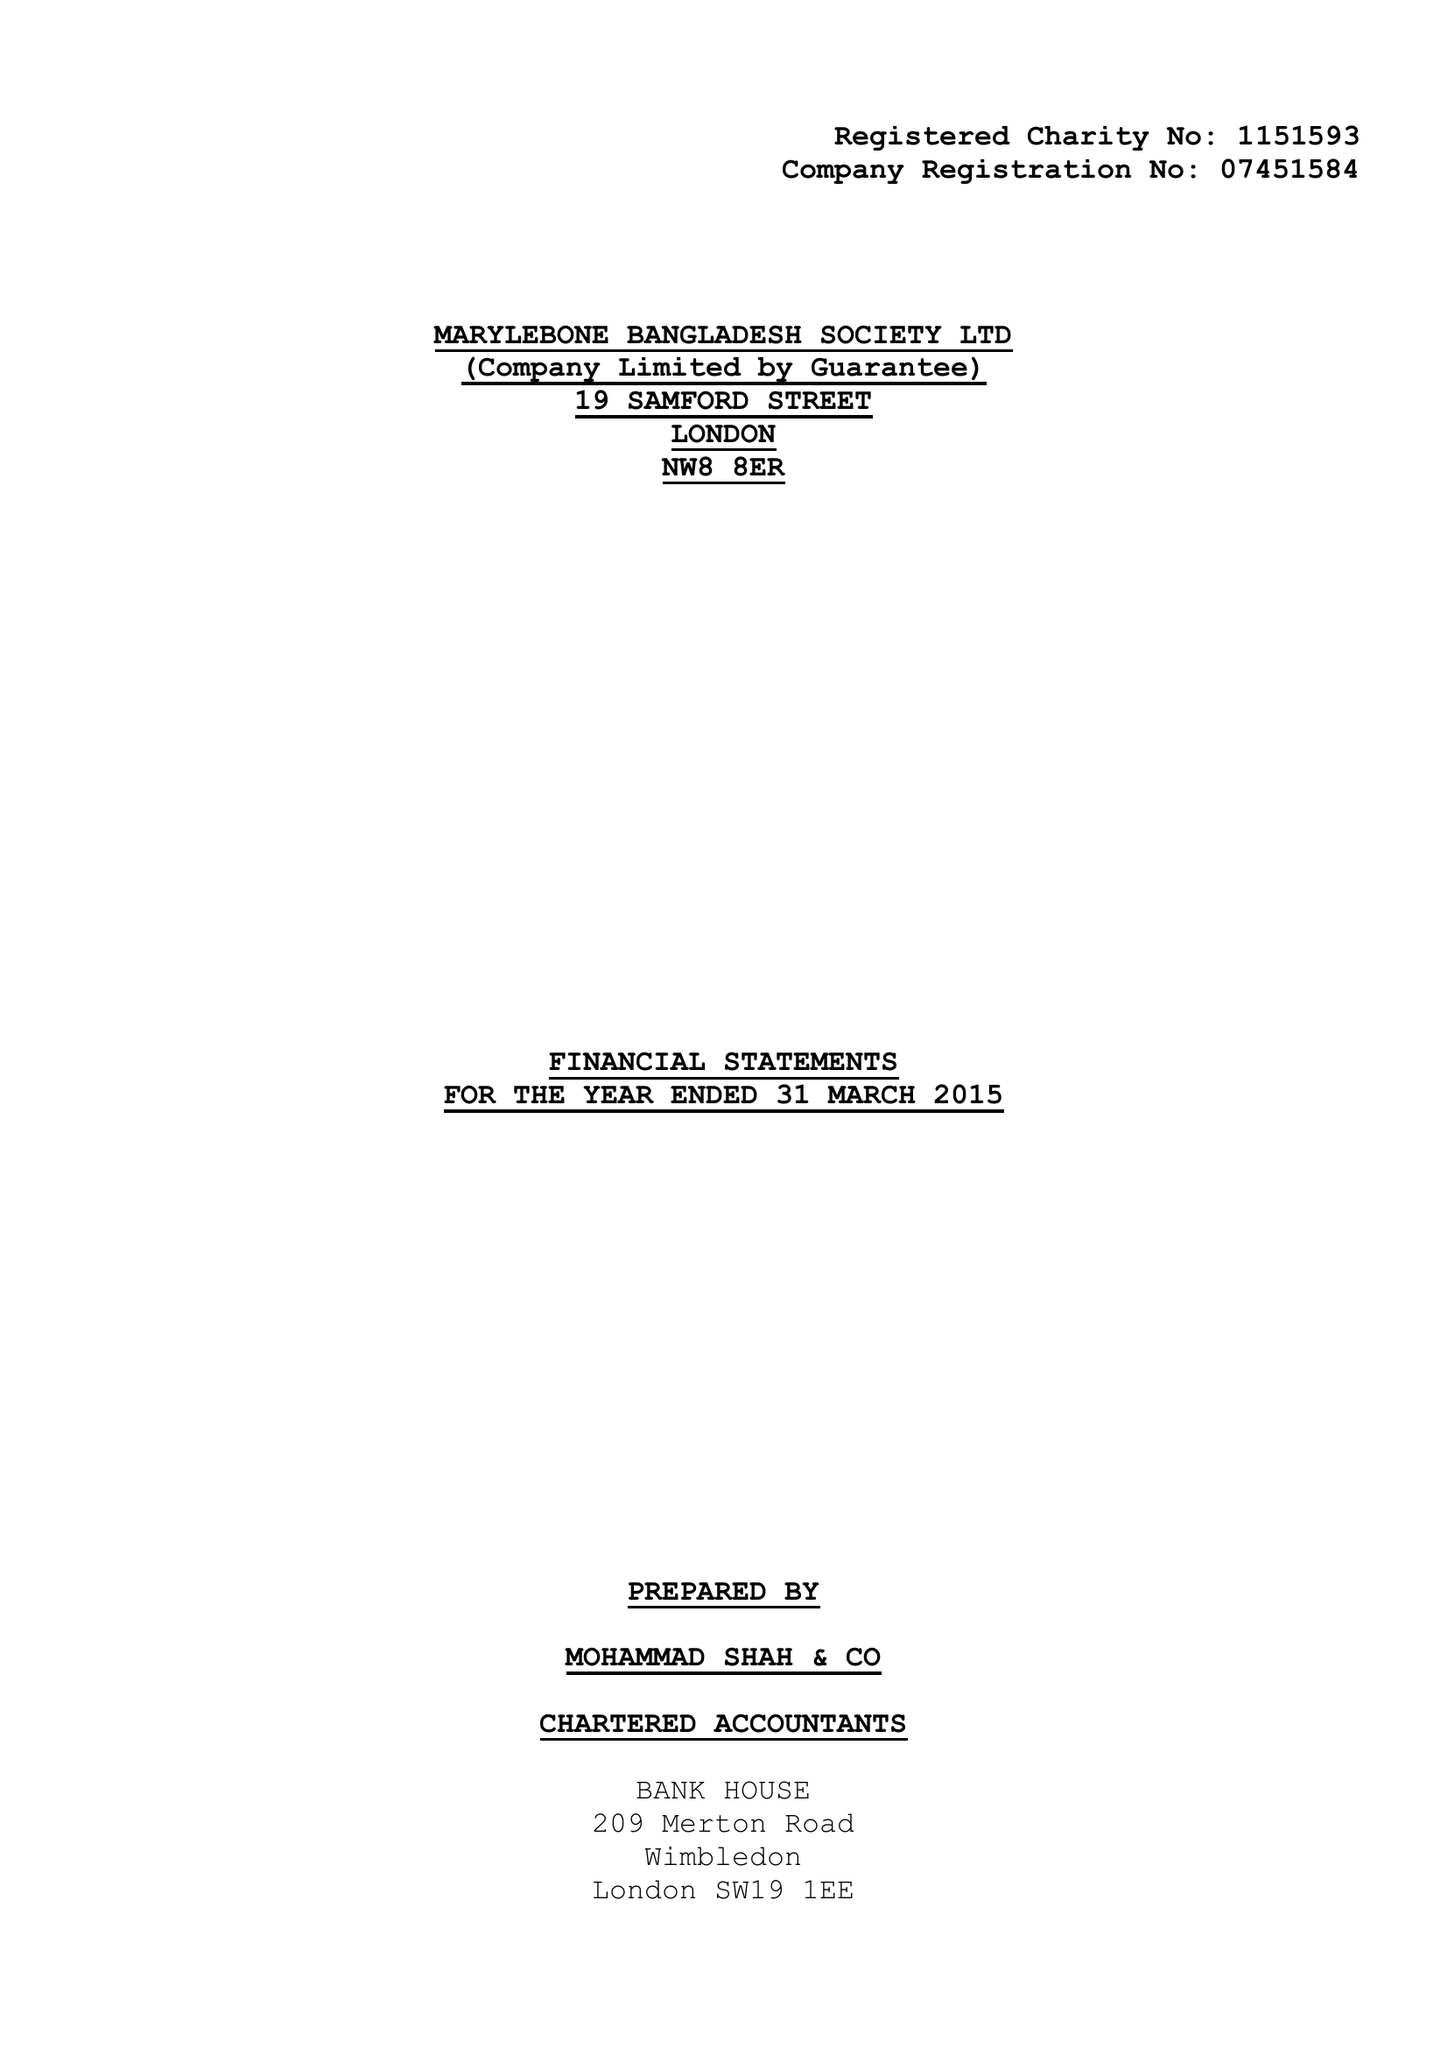What is the value for the income_annually_in_british_pounds?
Answer the question using a single word or phrase. 159418.00 